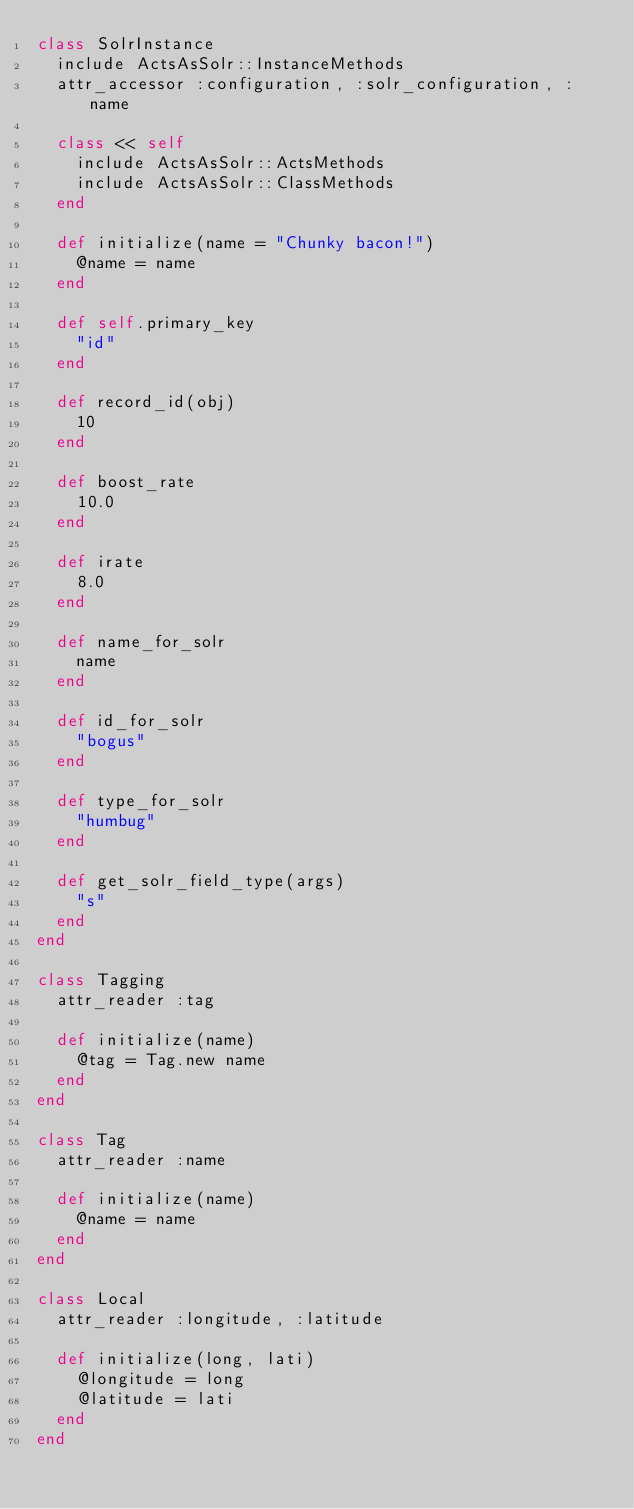Convert code to text. <code><loc_0><loc_0><loc_500><loc_500><_Ruby_>class SolrInstance
  include ActsAsSolr::InstanceMethods
  attr_accessor :configuration, :solr_configuration, :name

  class << self
    include ActsAsSolr::ActsMethods
    include ActsAsSolr::ClassMethods
  end

  def initialize(name = "Chunky bacon!")
    @name = name
  end
  
  def self.primary_key
    "id"
  end
  
  def record_id(obj)
    10
  end
  
  def boost_rate
    10.0
  end
  
  def irate
    8.0
  end

  def name_for_solr
    name
  end
  
  def id_for_solr
    "bogus"
  end
  
  def type_for_solr
    "humbug"
  end
  
  def get_solr_field_type(args)
    "s"
  end
end

class Tagging
  attr_reader :tag
  
  def initialize(name)
    @tag = Tag.new name
  end
end

class Tag
  attr_reader :name

  def initialize(name)
    @name = name
  end
end

class Local
  attr_reader :longitude, :latitude

  def initialize(long, lati)
    @longitude = long
    @latitude = lati
  end
end
</code> 